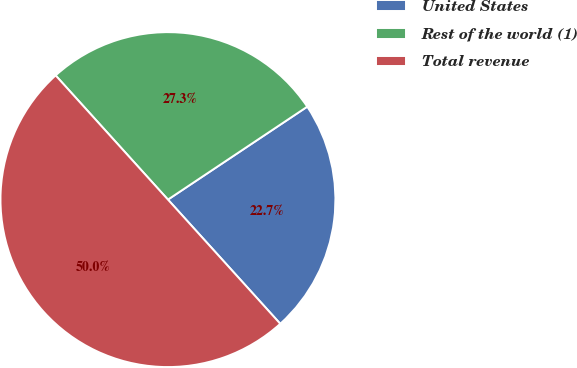<chart> <loc_0><loc_0><loc_500><loc_500><pie_chart><fcel>United States<fcel>Rest of the world (1)<fcel>Total revenue<nl><fcel>22.66%<fcel>27.34%<fcel>50.0%<nl></chart> 